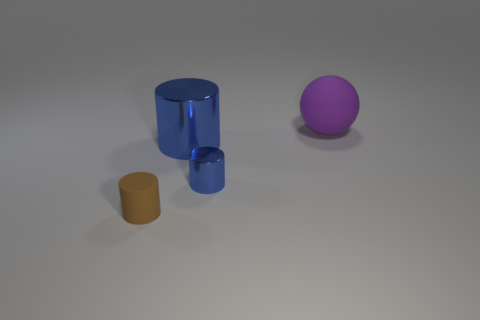Add 1 blue cylinders. How many objects exist? 5 Subtract all cylinders. How many objects are left? 1 Subtract 0 cyan cylinders. How many objects are left? 4 Subtract all small blue cylinders. Subtract all gray metallic cylinders. How many objects are left? 3 Add 1 big blue metal things. How many big blue metal things are left? 2 Add 4 tiny gray blocks. How many tiny gray blocks exist? 4 